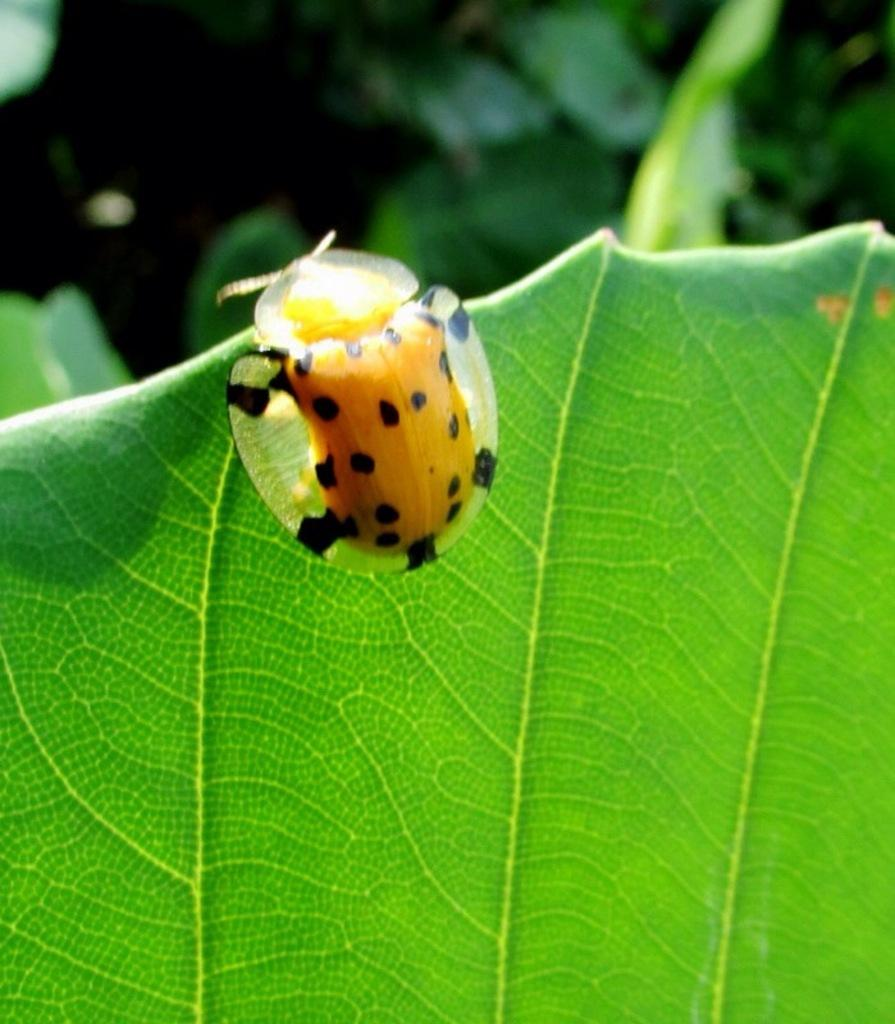What type of creature can be seen in the image? There is an insect in the image. Where is the insect located in the image? The insect is sitting on a leaf. What type of vegetation is present in the image? There are plants in the image. How many mice are playing with a bubble in the image? There are no mice or bubbles present in the image. What type of church can be seen in the image? There is no church present in the image. 